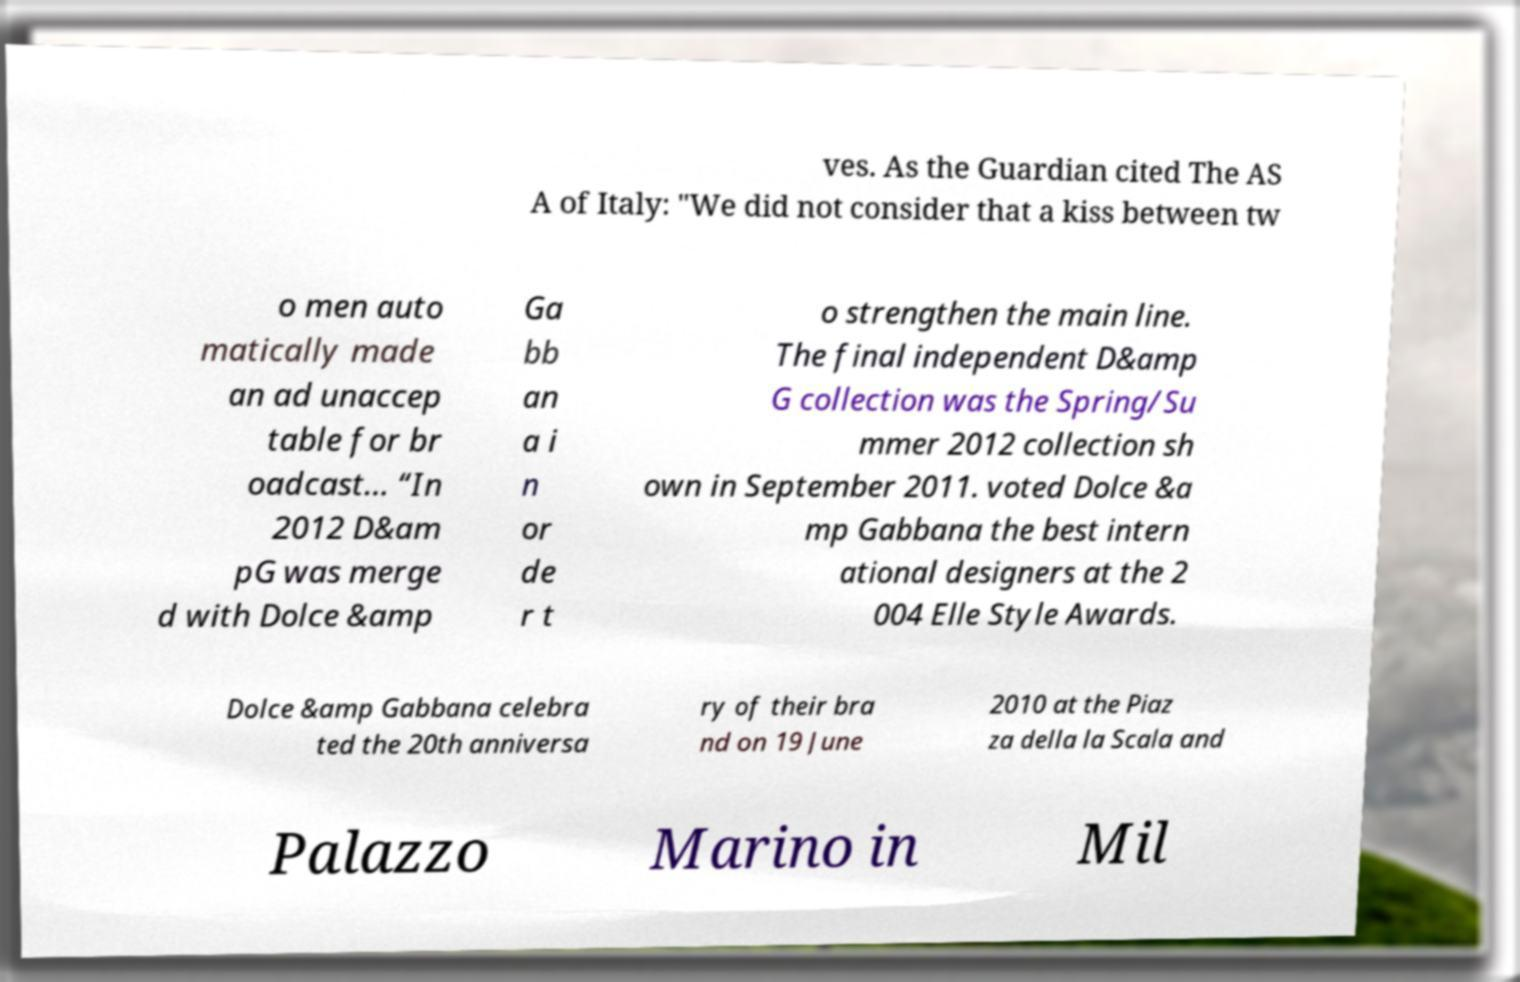I need the written content from this picture converted into text. Can you do that? ves. As the Guardian cited The AS A of Italy: "We did not consider that a kiss between tw o men auto matically made an ad unaccep table for br oadcast… “In 2012 D&am pG was merge d with Dolce &amp Ga bb an a i n or de r t o strengthen the main line. The final independent D&amp G collection was the Spring/Su mmer 2012 collection sh own in September 2011. voted Dolce &a mp Gabbana the best intern ational designers at the 2 004 Elle Style Awards. Dolce &amp Gabbana celebra ted the 20th anniversa ry of their bra nd on 19 June 2010 at the Piaz za della la Scala and Palazzo Marino in Mil 